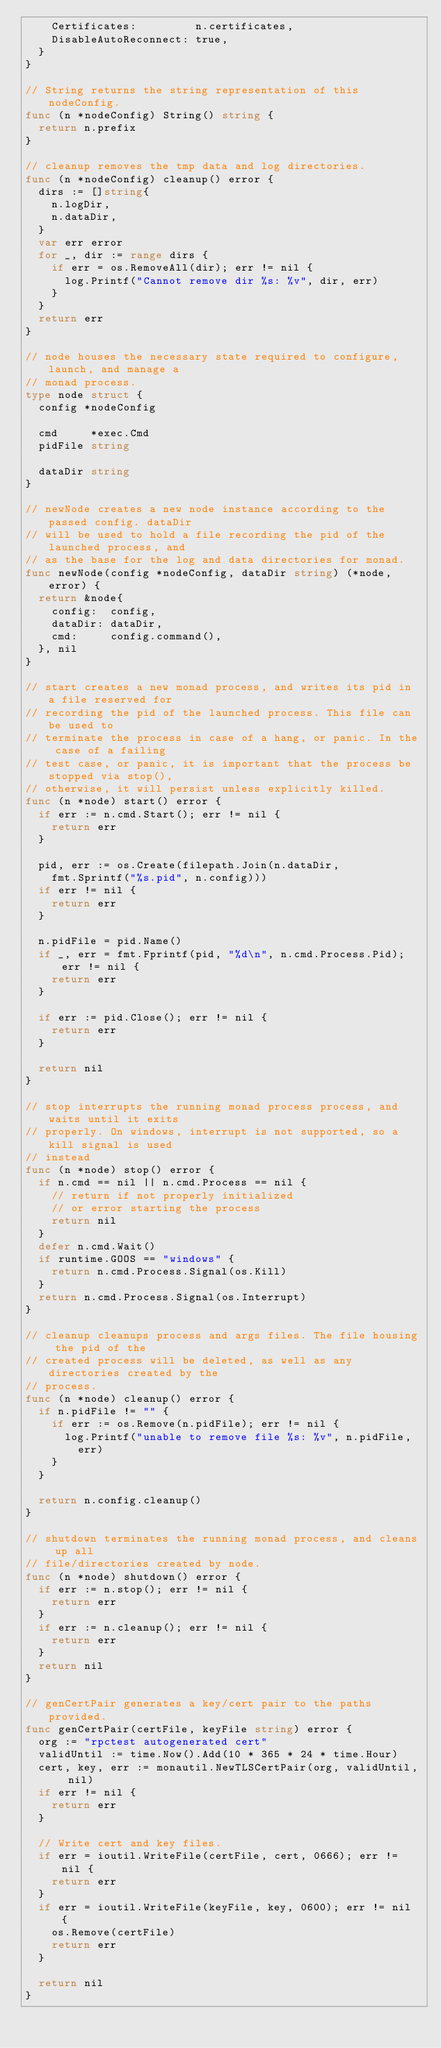Convert code to text. <code><loc_0><loc_0><loc_500><loc_500><_Go_>		Certificates:         n.certificates,
		DisableAutoReconnect: true,
	}
}

// String returns the string representation of this nodeConfig.
func (n *nodeConfig) String() string {
	return n.prefix
}

// cleanup removes the tmp data and log directories.
func (n *nodeConfig) cleanup() error {
	dirs := []string{
		n.logDir,
		n.dataDir,
	}
	var err error
	for _, dir := range dirs {
		if err = os.RemoveAll(dir); err != nil {
			log.Printf("Cannot remove dir %s: %v", dir, err)
		}
	}
	return err
}

// node houses the necessary state required to configure, launch, and manage a
// monad process.
type node struct {
	config *nodeConfig

	cmd     *exec.Cmd
	pidFile string

	dataDir string
}

// newNode creates a new node instance according to the passed config. dataDir
// will be used to hold a file recording the pid of the launched process, and
// as the base for the log and data directories for monad.
func newNode(config *nodeConfig, dataDir string) (*node, error) {
	return &node{
		config:  config,
		dataDir: dataDir,
		cmd:     config.command(),
	}, nil
}

// start creates a new monad process, and writes its pid in a file reserved for
// recording the pid of the launched process. This file can be used to
// terminate the process in case of a hang, or panic. In the case of a failing
// test case, or panic, it is important that the process be stopped via stop(),
// otherwise, it will persist unless explicitly killed.
func (n *node) start() error {
	if err := n.cmd.Start(); err != nil {
		return err
	}

	pid, err := os.Create(filepath.Join(n.dataDir,
		fmt.Sprintf("%s.pid", n.config)))
	if err != nil {
		return err
	}

	n.pidFile = pid.Name()
	if _, err = fmt.Fprintf(pid, "%d\n", n.cmd.Process.Pid); err != nil {
		return err
	}

	if err := pid.Close(); err != nil {
		return err
	}

	return nil
}

// stop interrupts the running monad process process, and waits until it exits
// properly. On windows, interrupt is not supported, so a kill signal is used
// instead
func (n *node) stop() error {
	if n.cmd == nil || n.cmd.Process == nil {
		// return if not properly initialized
		// or error starting the process
		return nil
	}
	defer n.cmd.Wait()
	if runtime.GOOS == "windows" {
		return n.cmd.Process.Signal(os.Kill)
	}
	return n.cmd.Process.Signal(os.Interrupt)
}

// cleanup cleanups process and args files. The file housing the pid of the
// created process will be deleted, as well as any directories created by the
// process.
func (n *node) cleanup() error {
	if n.pidFile != "" {
		if err := os.Remove(n.pidFile); err != nil {
			log.Printf("unable to remove file %s: %v", n.pidFile,
				err)
		}
	}

	return n.config.cleanup()
}

// shutdown terminates the running monad process, and cleans up all
// file/directories created by node.
func (n *node) shutdown() error {
	if err := n.stop(); err != nil {
		return err
	}
	if err := n.cleanup(); err != nil {
		return err
	}
	return nil
}

// genCertPair generates a key/cert pair to the paths provided.
func genCertPair(certFile, keyFile string) error {
	org := "rpctest autogenerated cert"
	validUntil := time.Now().Add(10 * 365 * 24 * time.Hour)
	cert, key, err := monautil.NewTLSCertPair(org, validUntil, nil)
	if err != nil {
		return err
	}

	// Write cert and key files.
	if err = ioutil.WriteFile(certFile, cert, 0666); err != nil {
		return err
	}
	if err = ioutil.WriteFile(keyFile, key, 0600); err != nil {
		os.Remove(certFile)
		return err
	}

	return nil
}
</code> 